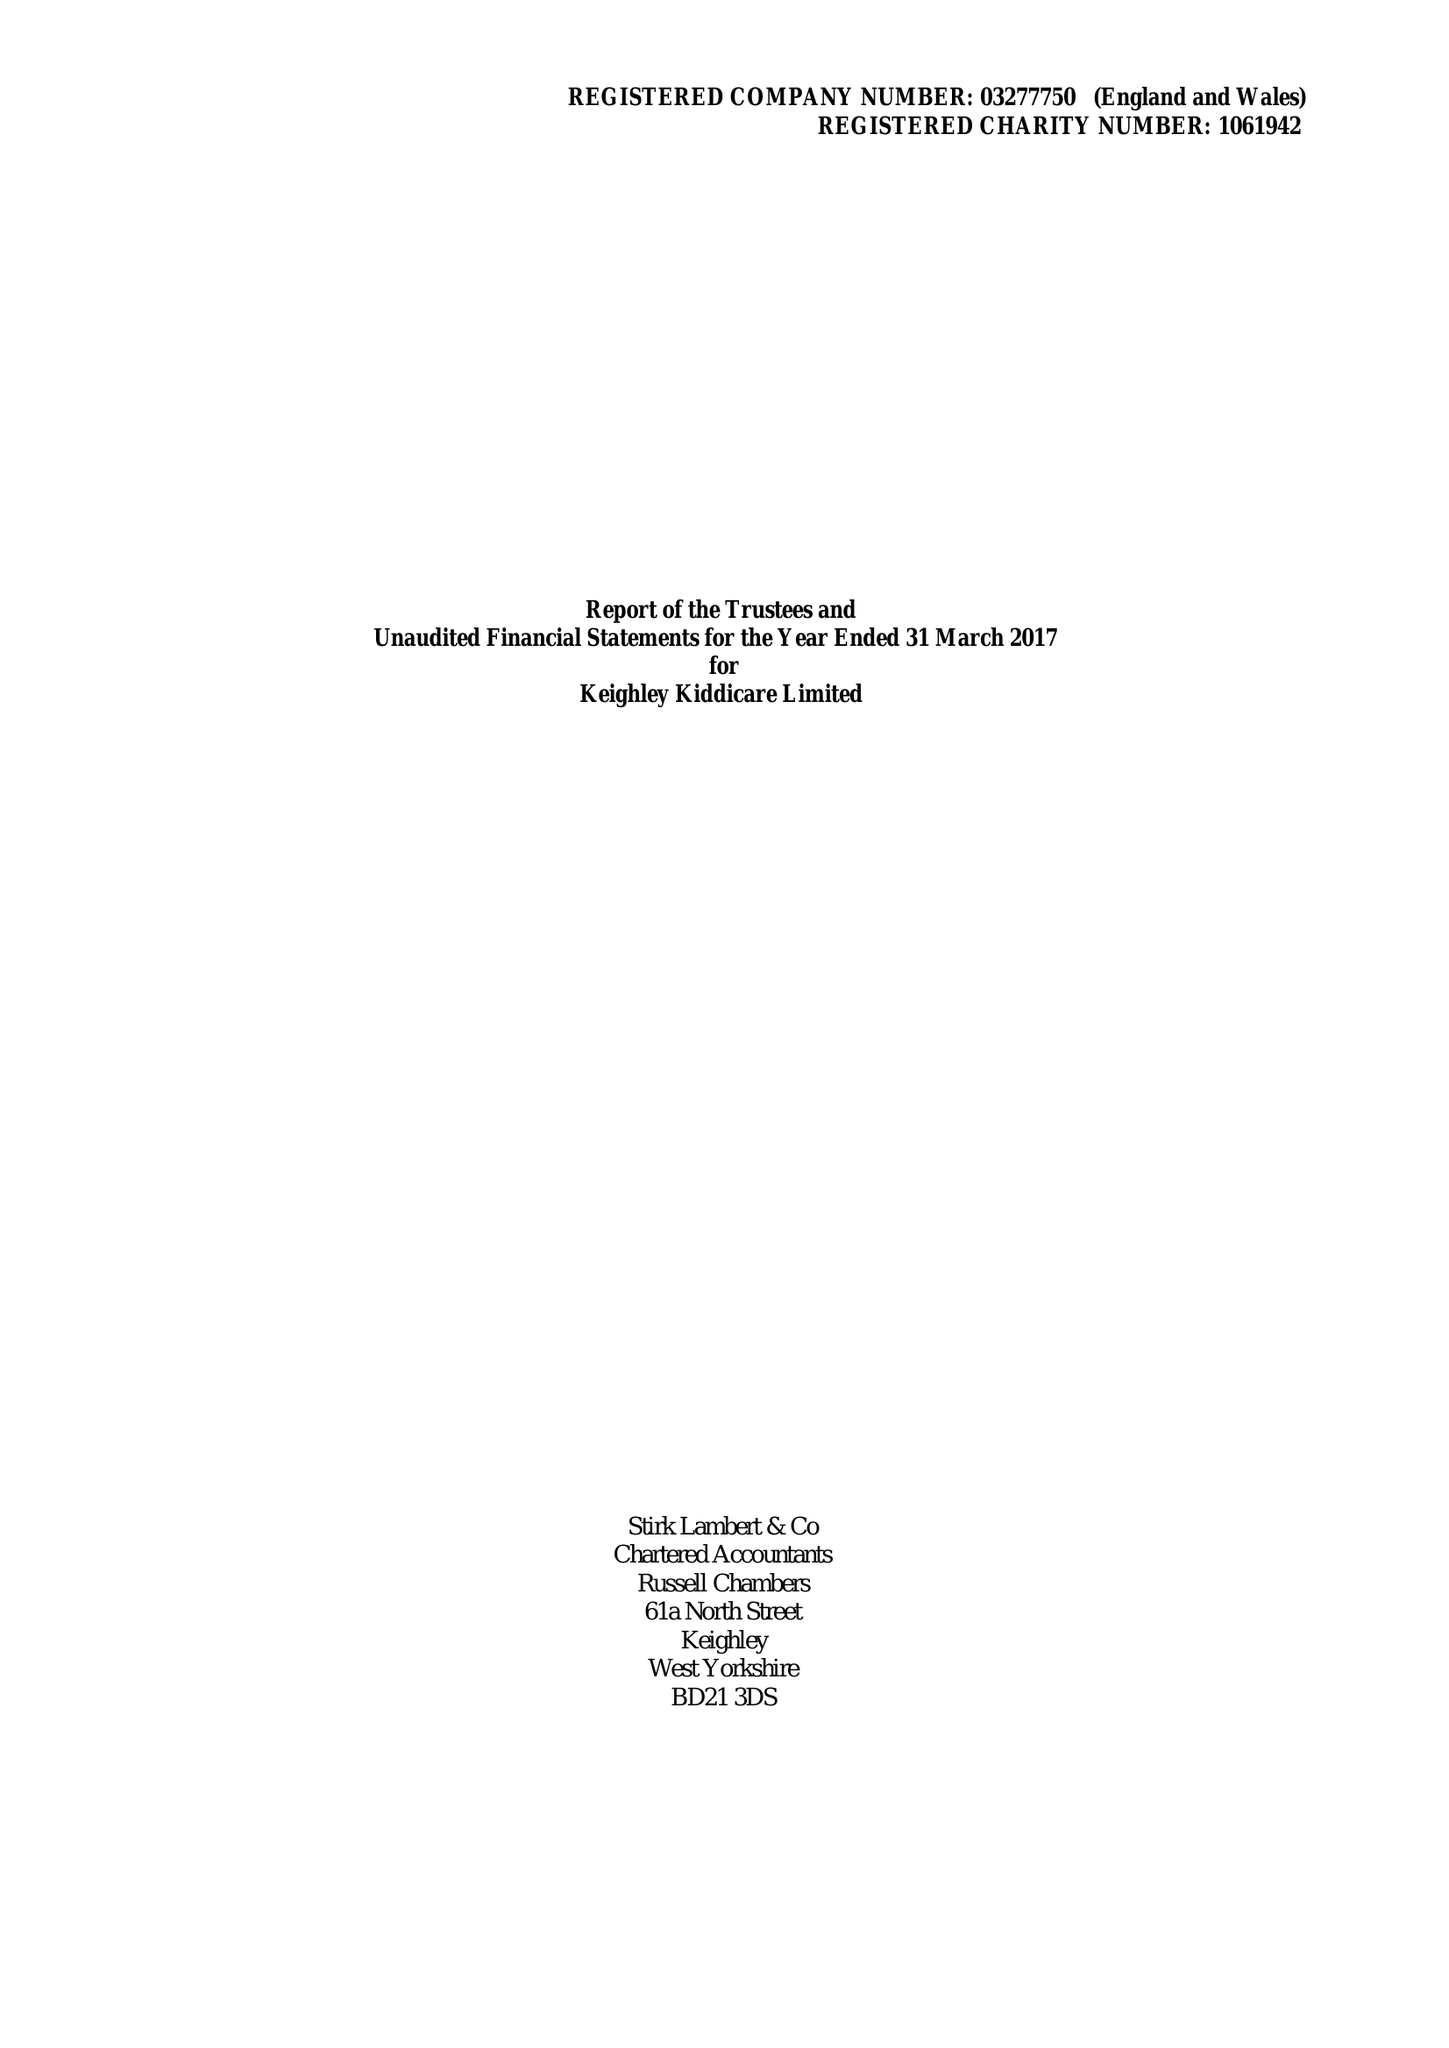What is the value for the charity_number?
Answer the question using a single word or phrase. 1061942 